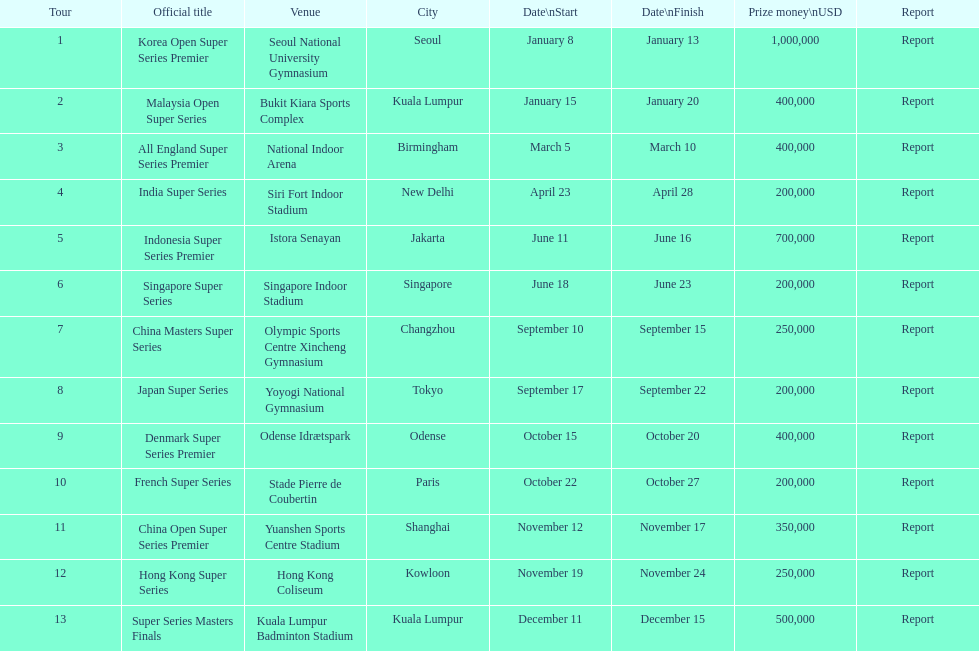What is the duration of the japan super series in days? 5. 